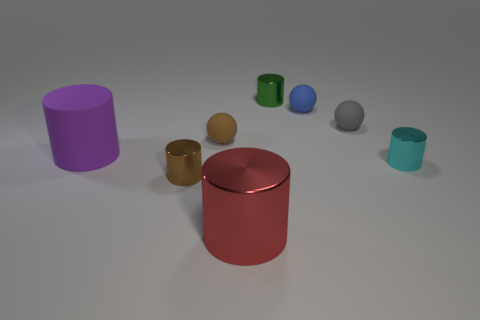Add 2 green rubber blocks. How many objects exist? 10 Subtract all large metallic cylinders. How many cylinders are left? 4 Subtract 1 spheres. How many spheres are left? 2 Subtract all spheres. How many objects are left? 5 Subtract all purple cylinders. How many cylinders are left? 4 Subtract all gray shiny cubes. Subtract all cyan cylinders. How many objects are left? 7 Add 2 small brown things. How many small brown things are left? 4 Add 1 large green rubber cylinders. How many large green rubber cylinders exist? 1 Subtract 0 cyan spheres. How many objects are left? 8 Subtract all purple spheres. Subtract all brown cubes. How many spheres are left? 3 